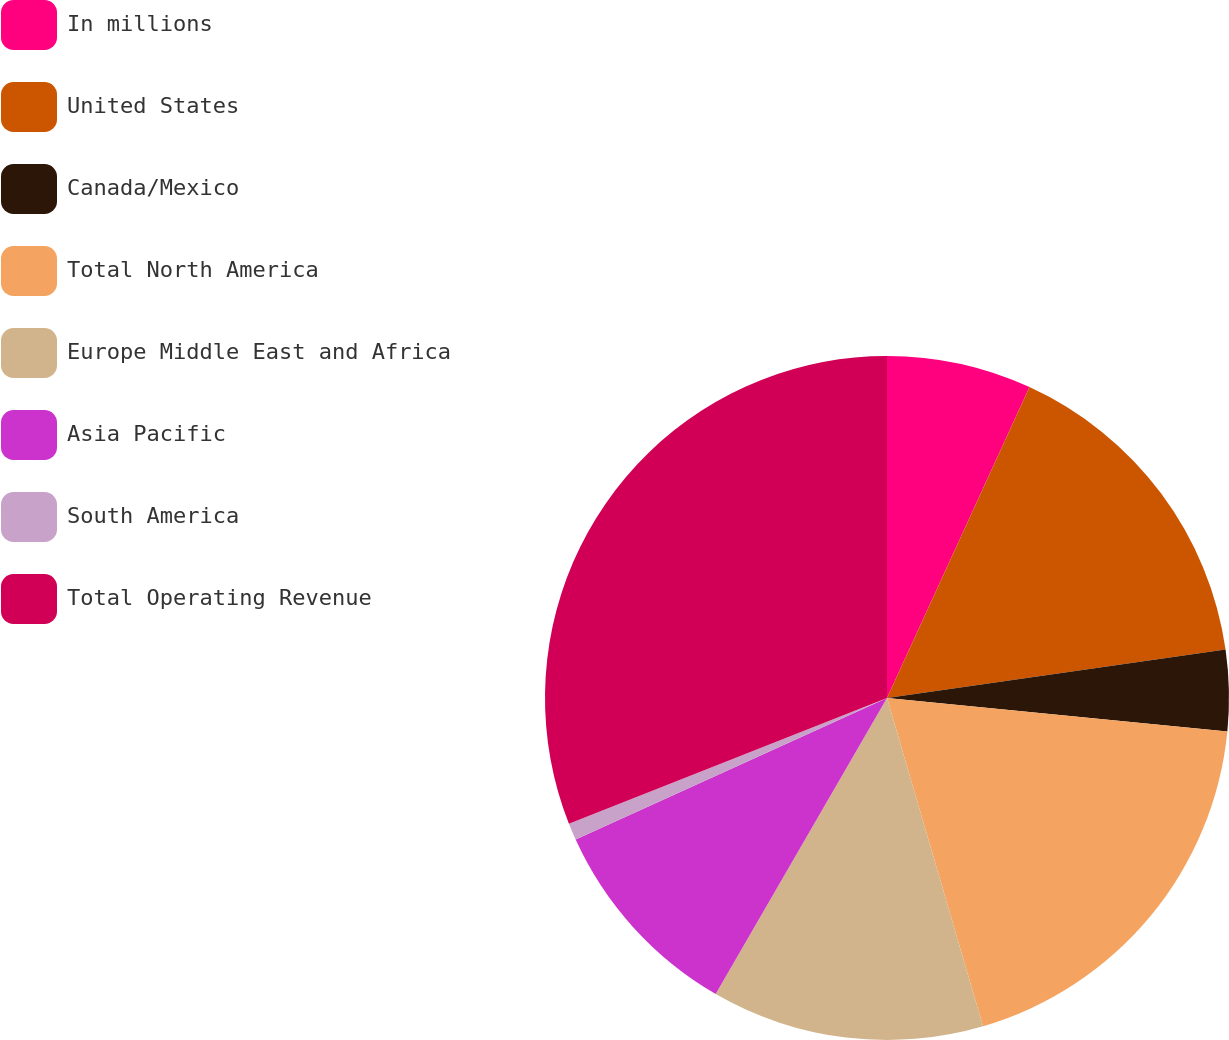Convert chart. <chart><loc_0><loc_0><loc_500><loc_500><pie_chart><fcel>In millions<fcel>United States<fcel>Canada/Mexico<fcel>Total North America<fcel>Europe Middle East and Africa<fcel>Asia Pacific<fcel>South America<fcel>Total Operating Revenue<nl><fcel>6.84%<fcel>15.9%<fcel>3.82%<fcel>18.91%<fcel>12.88%<fcel>9.86%<fcel>0.8%<fcel>30.99%<nl></chart> 